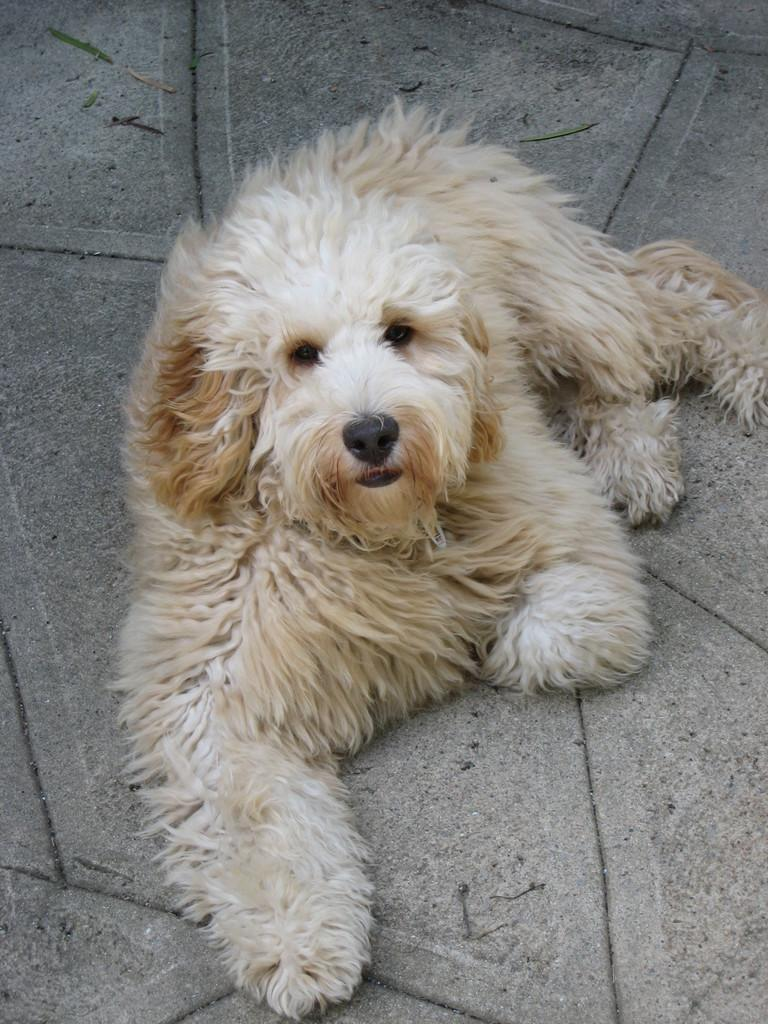What type of animal is present in the image? There is a dog in the image. Can you describe the color pattern of the dog? The dog is white and brown in color. What is the dog doing in the image? The dog is resting on the ground. How does the dog feel about taking a bath in the image? There is no indication in the image that the dog is about to take a bath or has any feelings about it. 